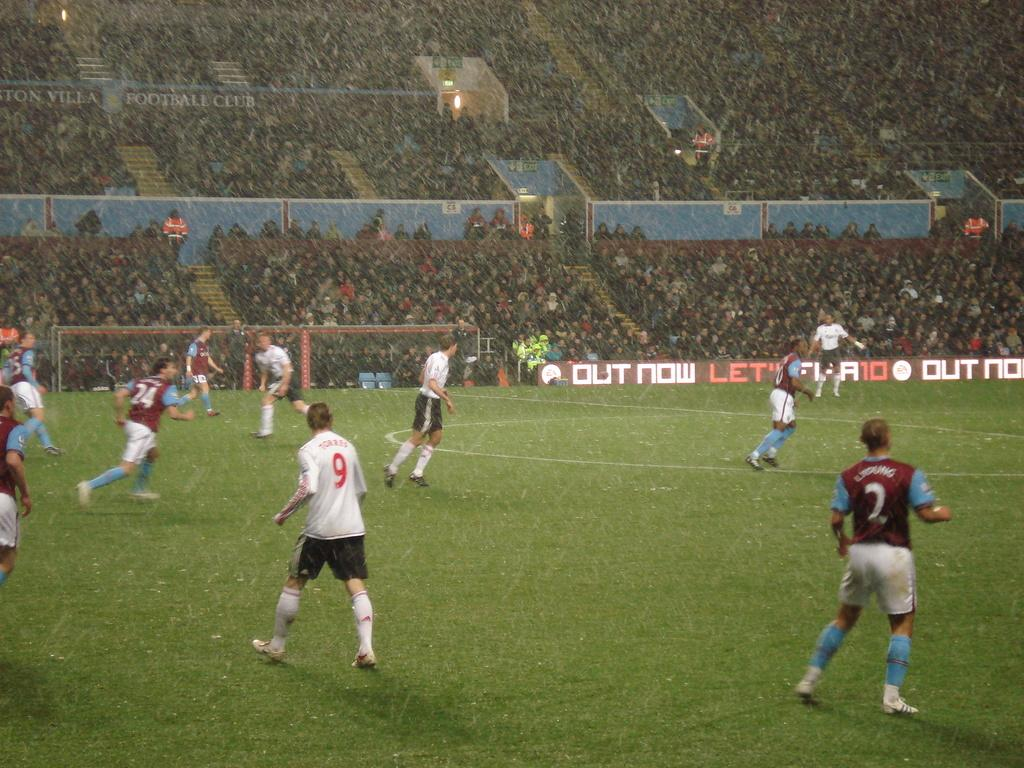<image>
Provide a brief description of the given image. the number 9 is on the jersey of the player 